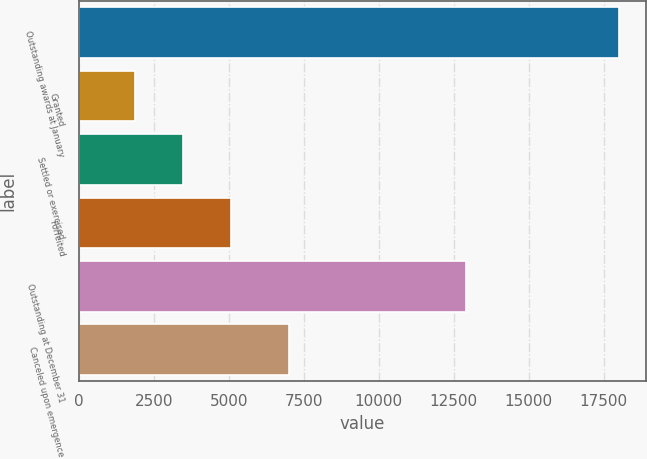Convert chart. <chart><loc_0><loc_0><loc_500><loc_500><bar_chart><fcel>Outstanding awards at January<fcel>Granted<fcel>Settled or exercised<fcel>Forfeited<fcel>Outstanding at December 31<fcel>Canceled upon emergence<nl><fcel>18015<fcel>1864<fcel>3479.1<fcel>5094.2<fcel>12909<fcel>7009<nl></chart> 